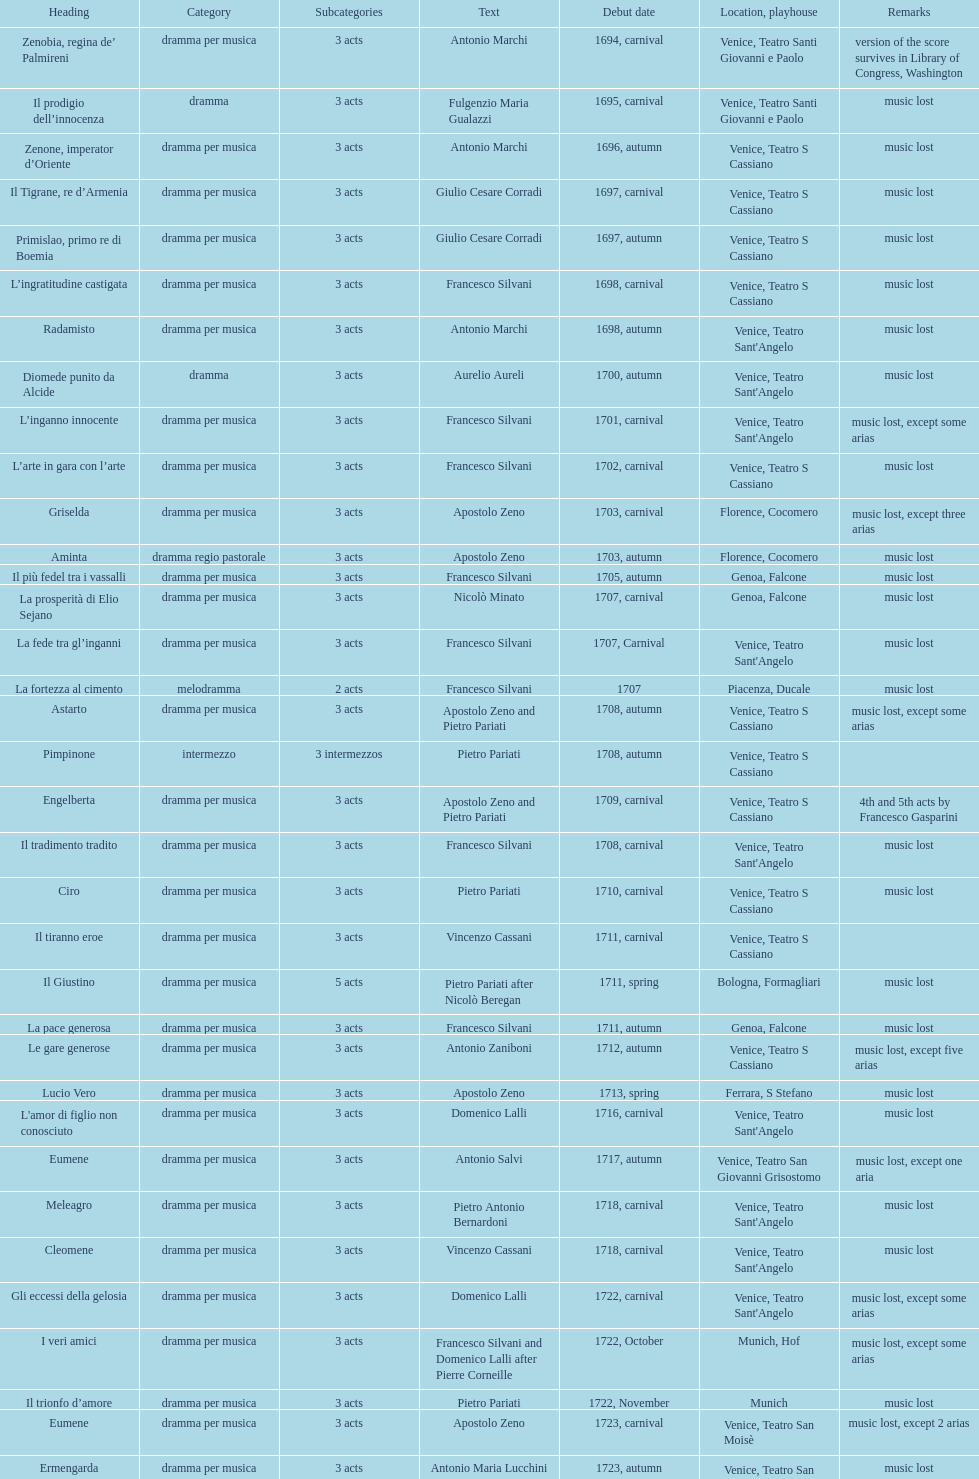L'inganno innocente premiered in 1701. what was the previous title released? Diomede punito da Alcide. 